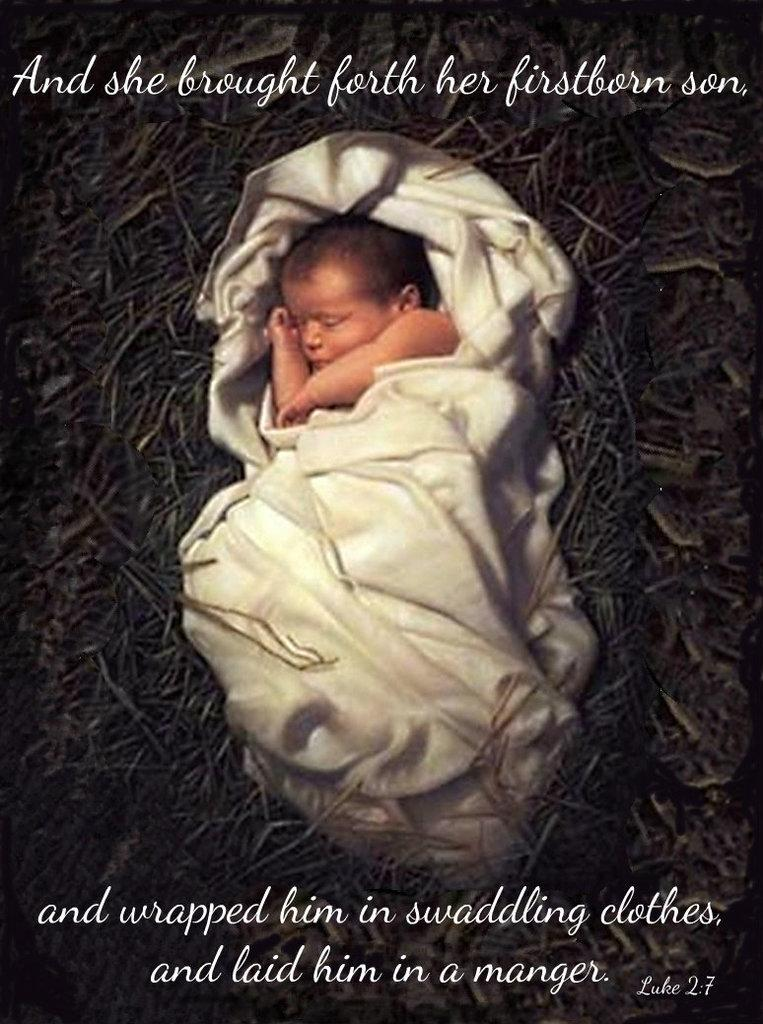What is the main subject of the image? There is a child in the image. What color is the cloth visible in the image? The cloth in the image is white. Can you describe the lighting in the image? The image appears to be slightly dark. How much debt does the child have in the image? There is no indication of debt in the image, as it features a child and a white cloth. 